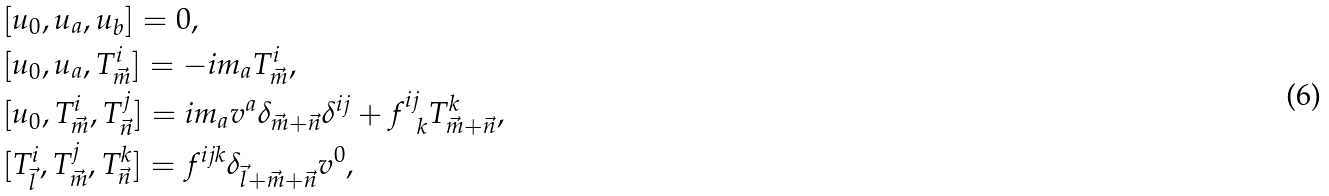<formula> <loc_0><loc_0><loc_500><loc_500>& [ u _ { 0 } , u _ { a } , u _ { b } ] = 0 , \\ & [ u _ { 0 } , u _ { a } , T ^ { i } _ { \vec { m } } ] = - i m _ { a } T ^ { i } _ { \vec { m } } , \\ & [ u _ { 0 } , T ^ { i } _ { \vec { m } } , T ^ { j } _ { \vec { n } } ] = i m _ { a } v ^ { a } \delta _ { \vec { m } + \vec { n } } \delta ^ { i j } + f ^ { i j } _ { \ \ k } T ^ { k } _ { \vec { m } + \vec { n } } , \\ & [ T ^ { i } _ { \vec { l } } , T ^ { j } _ { \vec { m } } , T ^ { k } _ { \vec { n } } ] = f ^ { i j k } \delta _ { \vec { l } + \vec { m } + \vec { n } } v ^ { 0 } ,</formula> 